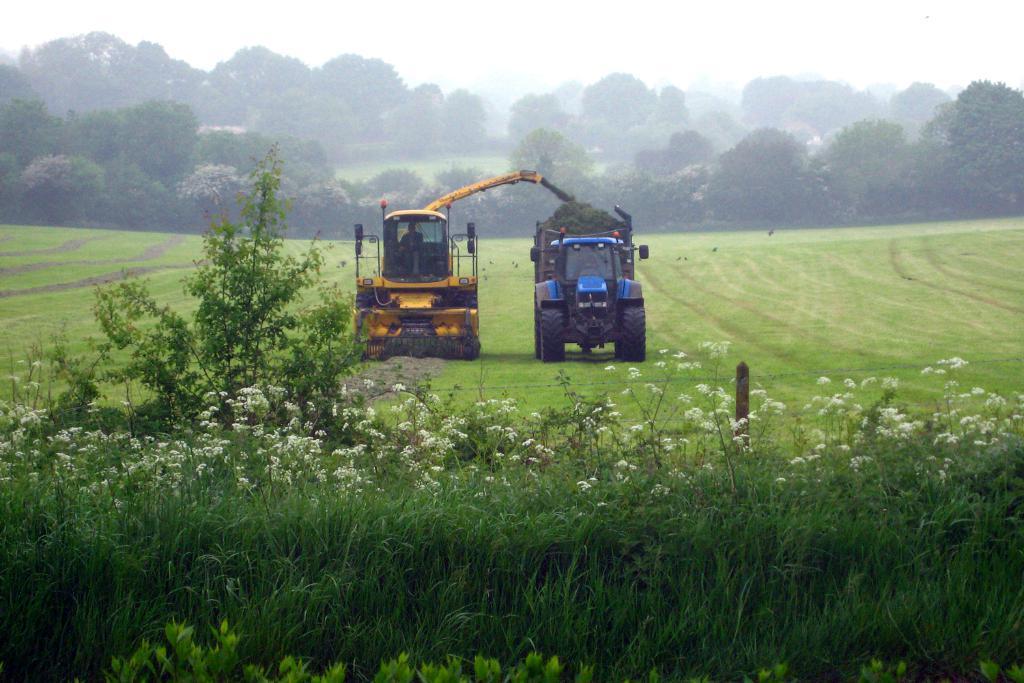In one or two sentences, can you explain what this image depicts? In the image in the center, we can see two vehicles, which are in blue and yellow color. In the background, we can see the sky, trees, plants, grass and flowers. 